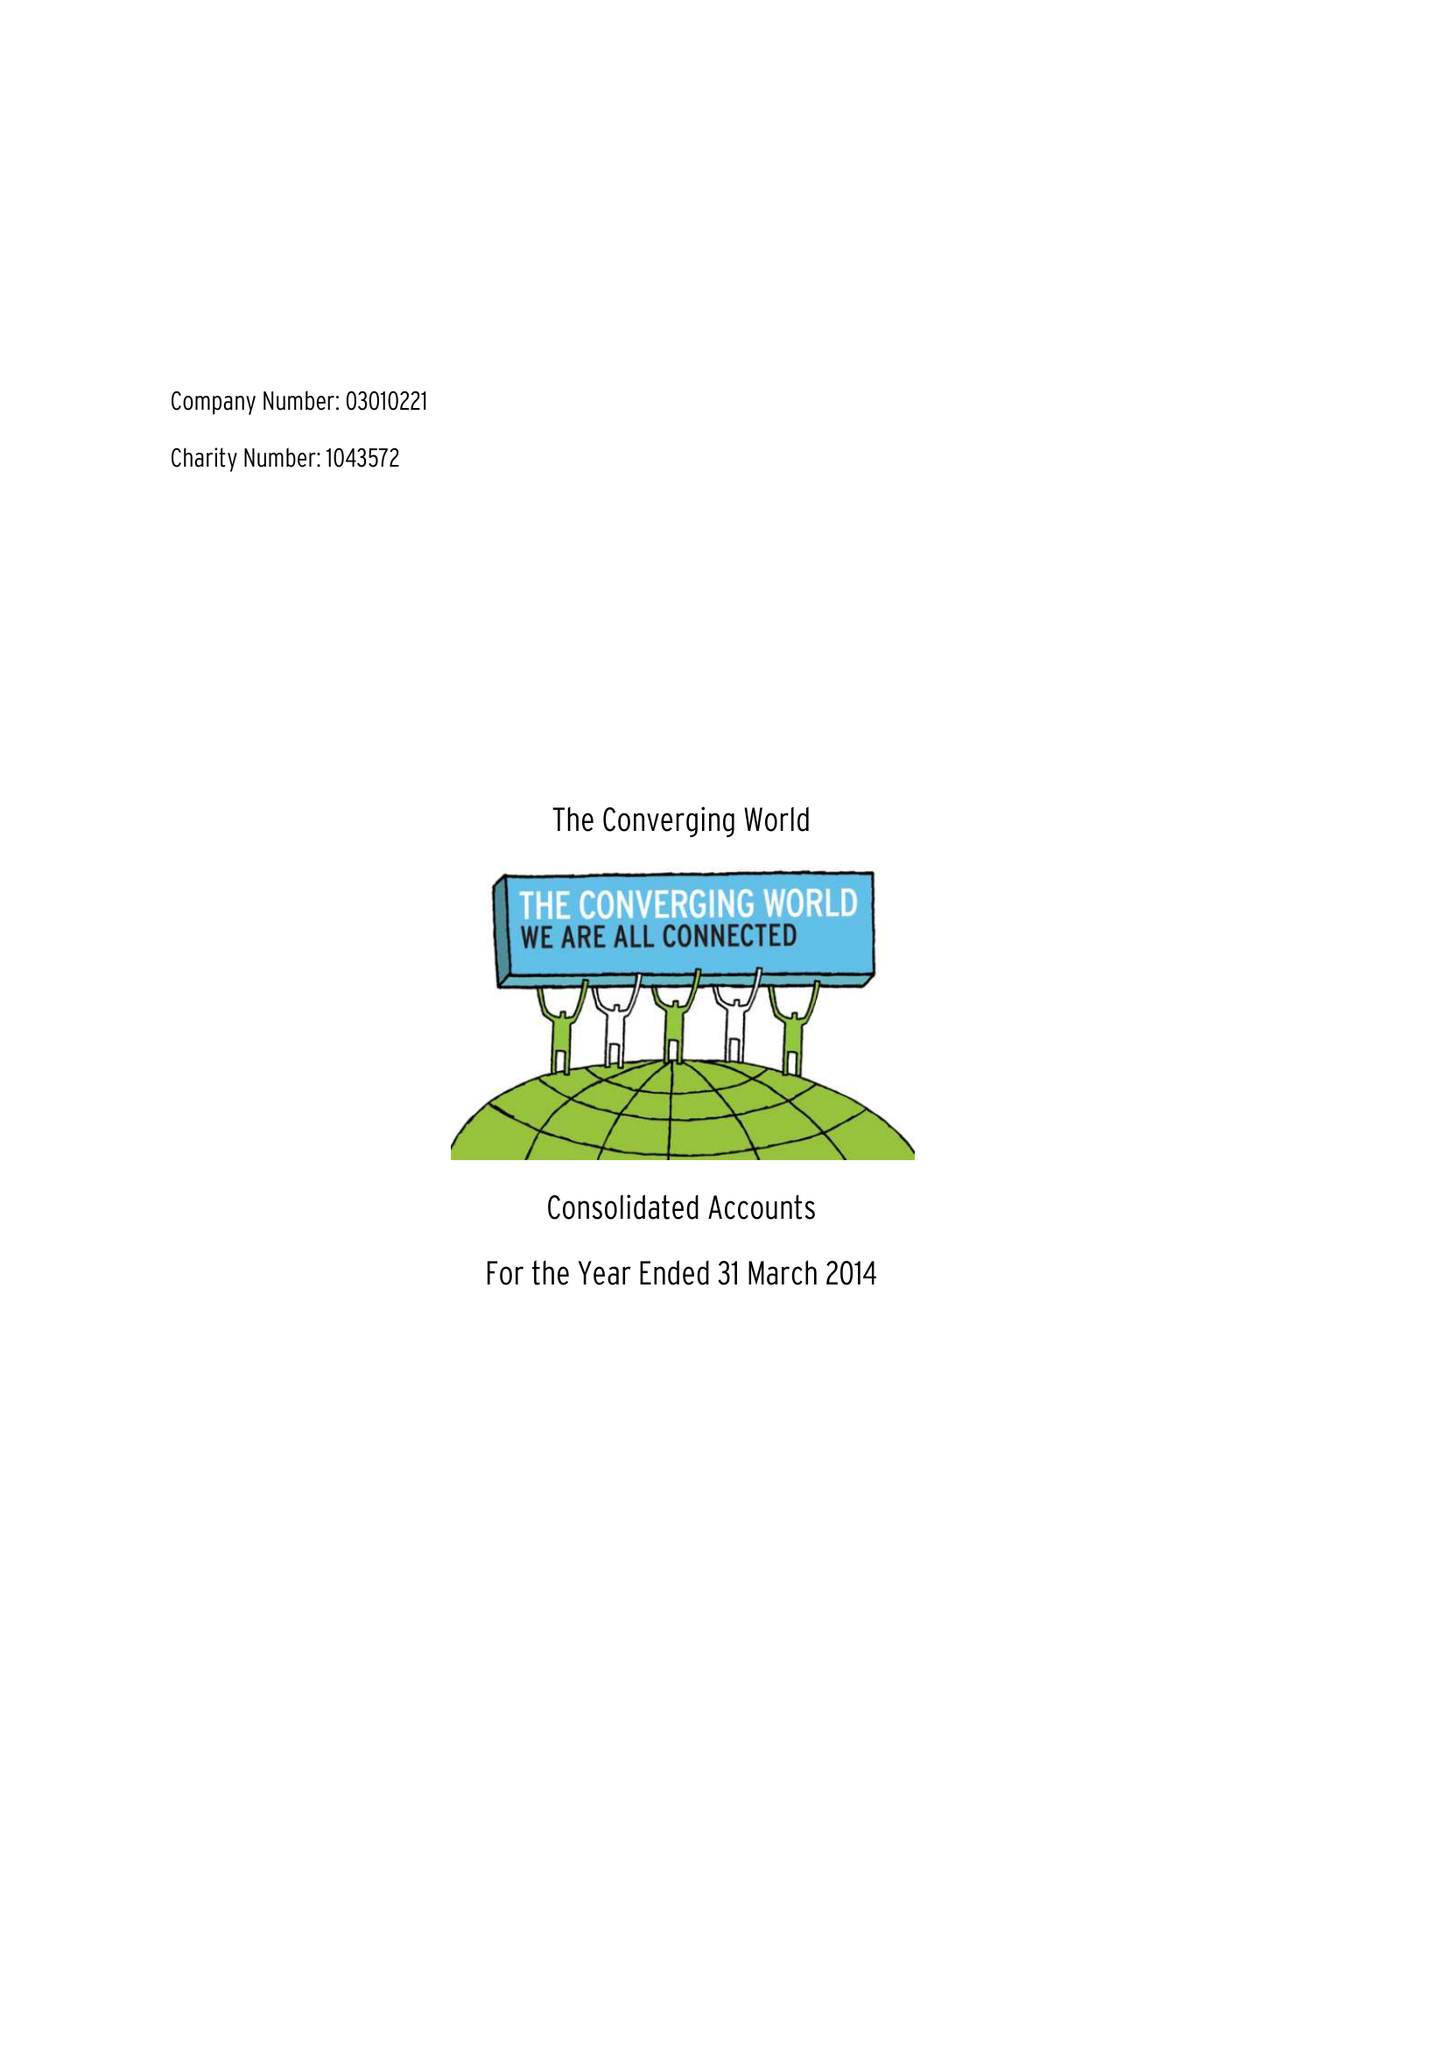What is the value for the address__postcode?
Answer the question using a single word or phrase. BS40 8SP 